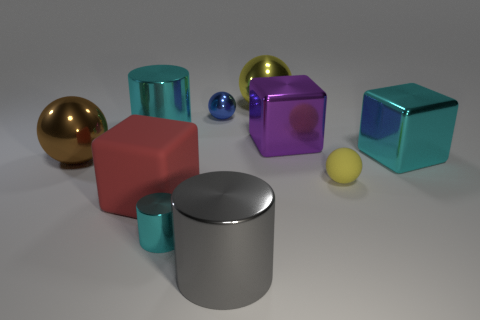Imagine these objects are part of a playground. What games could kids play with them? In a whimsical playground setting, these geometric shapes could inspire various imaginative games. Children might pretend the spheres are planets in a solar system, using the cubes as building blocks to create structures or even an obstacle course. The cylinders could serve as tunnels or pedestals in their inventive scenarios. 